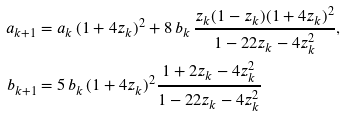<formula> <loc_0><loc_0><loc_500><loc_500>a _ { k + 1 } & = a _ { k } \, ( 1 + 4 z _ { k } ) ^ { 2 } + 8 \, b _ { k } \, \frac { z _ { k } ( 1 - z _ { k } ) ( 1 + 4 z _ { k } ) ^ { 2 } } { 1 - 2 2 z _ { k } - 4 z _ { k } ^ { 2 } } , \\ b _ { k + 1 } & = 5 \, b _ { k } \, ( 1 + 4 z _ { k } ) ^ { 2 } \frac { 1 + 2 z _ { k } - 4 z _ { k } ^ { 2 } } { 1 - 2 2 z _ { k } - 4 z _ { k } ^ { 2 } }</formula> 